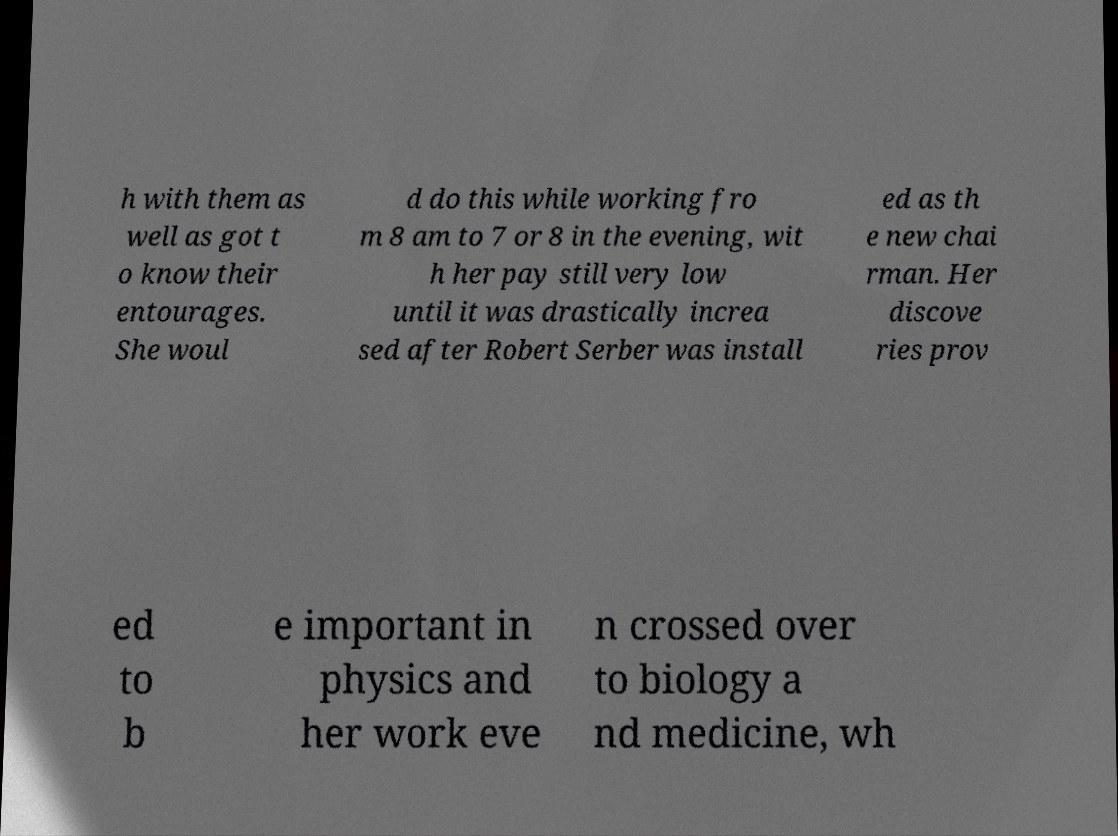Please identify and transcribe the text found in this image. h with them as well as got t o know their entourages. She woul d do this while working fro m 8 am to 7 or 8 in the evening, wit h her pay still very low until it was drastically increa sed after Robert Serber was install ed as th e new chai rman. Her discove ries prov ed to b e important in physics and her work eve n crossed over to biology a nd medicine, wh 